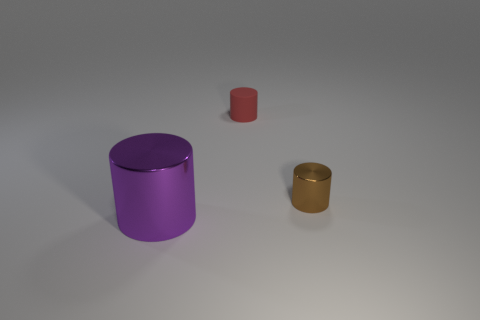What number of spheres have the same material as the purple object?
Offer a terse response. 0. There is a object that is the same material as the large cylinder; what color is it?
Your answer should be very brief. Brown. Do the matte cylinder and the metal thing that is to the right of the large metal cylinder have the same size?
Keep it short and to the point. Yes. There is a big purple thing; what shape is it?
Give a very brief answer. Cylinder. How many tiny metallic things have the same color as the large object?
Offer a very short reply. 0. What color is the other tiny thing that is the same shape as the tiny brown metal object?
Make the answer very short. Red. How many cylinders are left of the tiny thing that is on the right side of the small red matte cylinder?
Your answer should be very brief. 2. What number of blocks are either metallic objects or small brown things?
Give a very brief answer. 0. Are there any small brown metal cylinders?
Your response must be concise. Yes. There is a purple shiny object that is the same shape as the small matte thing; what size is it?
Offer a very short reply. Large. 